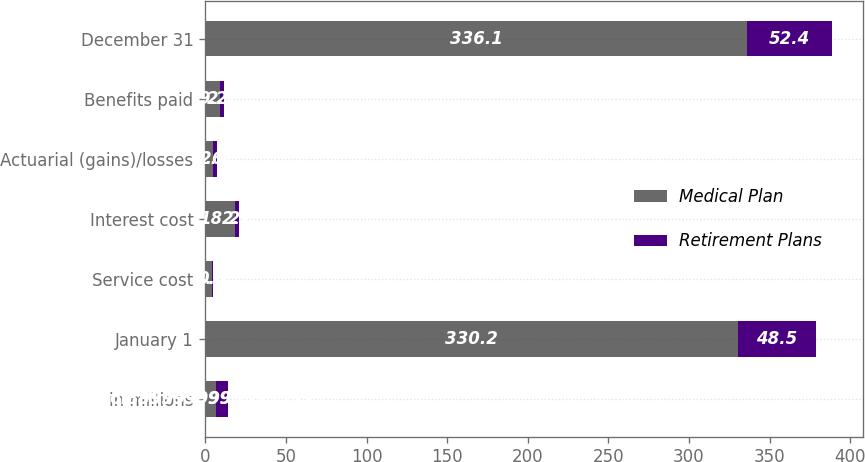<chart> <loc_0><loc_0><loc_500><loc_500><stacked_bar_chart><ecel><fcel>in millions<fcel>January 1<fcel>Service cost<fcel>Interest cost<fcel>Actuarial (gains)/losses<fcel>Benefits paid<fcel>December 31<nl><fcel>Medical Plan<fcel>6.9<fcel>330.2<fcel>4.1<fcel>18.2<fcel>4.6<fcel>9.2<fcel>336.1<nl><fcel>Retirement Plans<fcel>6.9<fcel>48.5<fcel>0.6<fcel>2.7<fcel>2.4<fcel>2.3<fcel>52.4<nl></chart> 